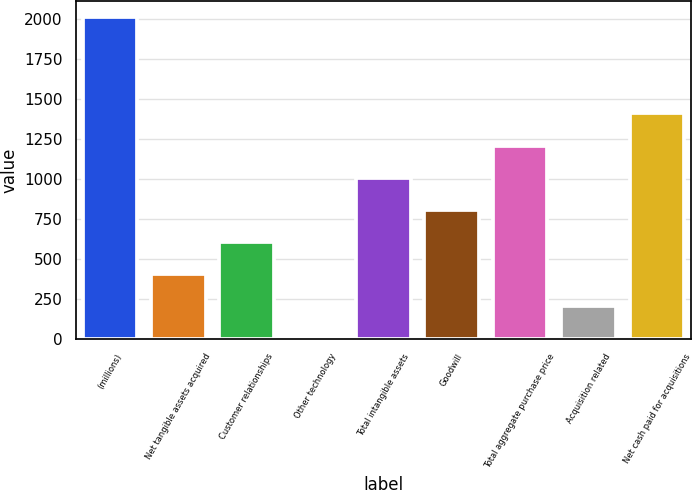Convert chart. <chart><loc_0><loc_0><loc_500><loc_500><bar_chart><fcel>(millions)<fcel>Net tangible assets acquired<fcel>Customer relationships<fcel>Other technology<fcel>Total intangible assets<fcel>Goodwill<fcel>Total aggregate purchase price<fcel>Acquisition related<fcel>Net cash paid for acquisitions<nl><fcel>2014<fcel>406.4<fcel>607.35<fcel>4.5<fcel>1009.25<fcel>808.3<fcel>1210.2<fcel>205.45<fcel>1411.15<nl></chart> 